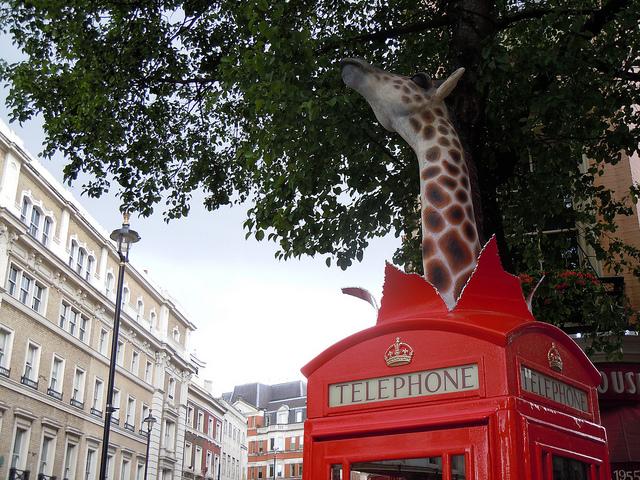What is sticking out of the telephone booth?
Keep it brief. Giraffe. What color is the telephone booth?
Quick response, please. Red. What is the giraffe in the picture?
Give a very brief answer. Statue. 